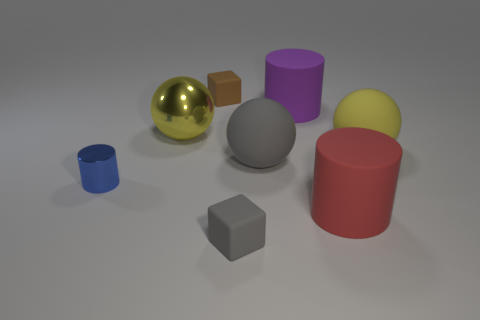There is a purple cylinder; is it the same size as the cube that is in front of the blue cylinder?
Give a very brief answer. No. How many matte objects are either large red things or purple cylinders?
Ensure brevity in your answer.  2. What number of yellow things are the same shape as the big gray thing?
Make the answer very short. 2. There is another object that is the same color as the big metallic thing; what is it made of?
Give a very brief answer. Rubber. There is a yellow thing behind the large yellow rubber ball; is it the same size as the matte thing on the left side of the small gray rubber cube?
Make the answer very short. No. What is the shape of the matte thing behind the large purple rubber object?
Offer a very short reply. Cube. Is the number of tiny gray cubes the same as the number of large blue metal things?
Your answer should be compact. No. There is a tiny gray object that is the same shape as the brown rubber thing; what is its material?
Keep it short and to the point. Rubber. There is a rubber cylinder that is behind the red matte object; does it have the same size as the small gray rubber cube?
Give a very brief answer. No. How many big purple cylinders are left of the shiny cylinder?
Provide a short and direct response. 0. 